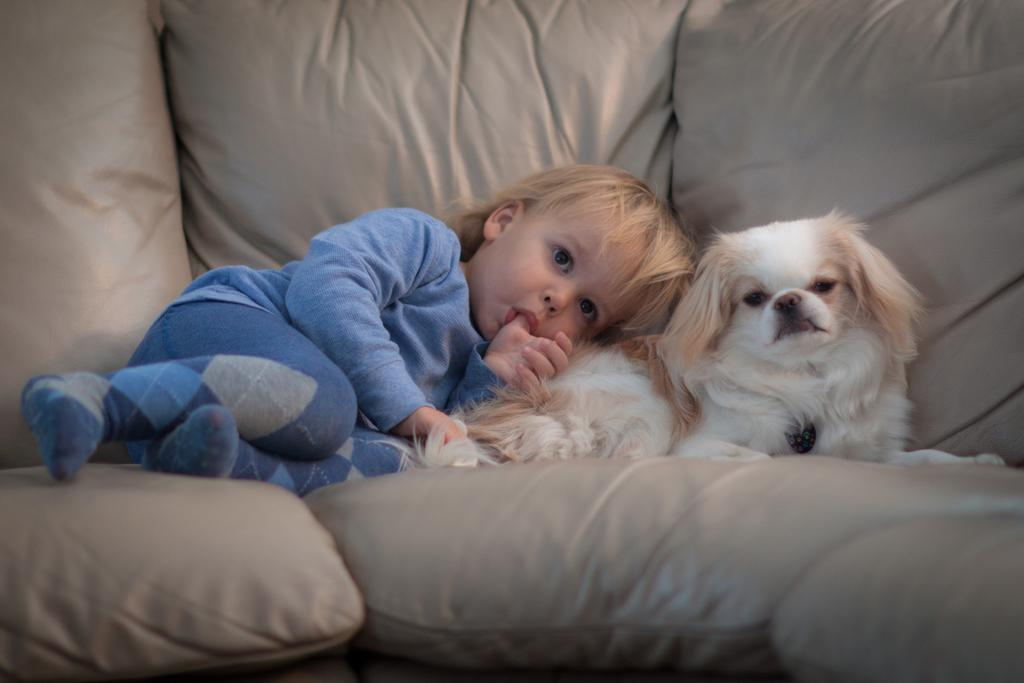Who or what is present in the image? There is a person and a dog in the image. What is the person doing in the image? The person is lying on a couch. What is the dog doing in the image? The dog is also lying on the couch. What type of cloth is the owl using to cover itself in the image? There is no owl present in the image, so it is not possible to determine what type of cloth it might be using. 